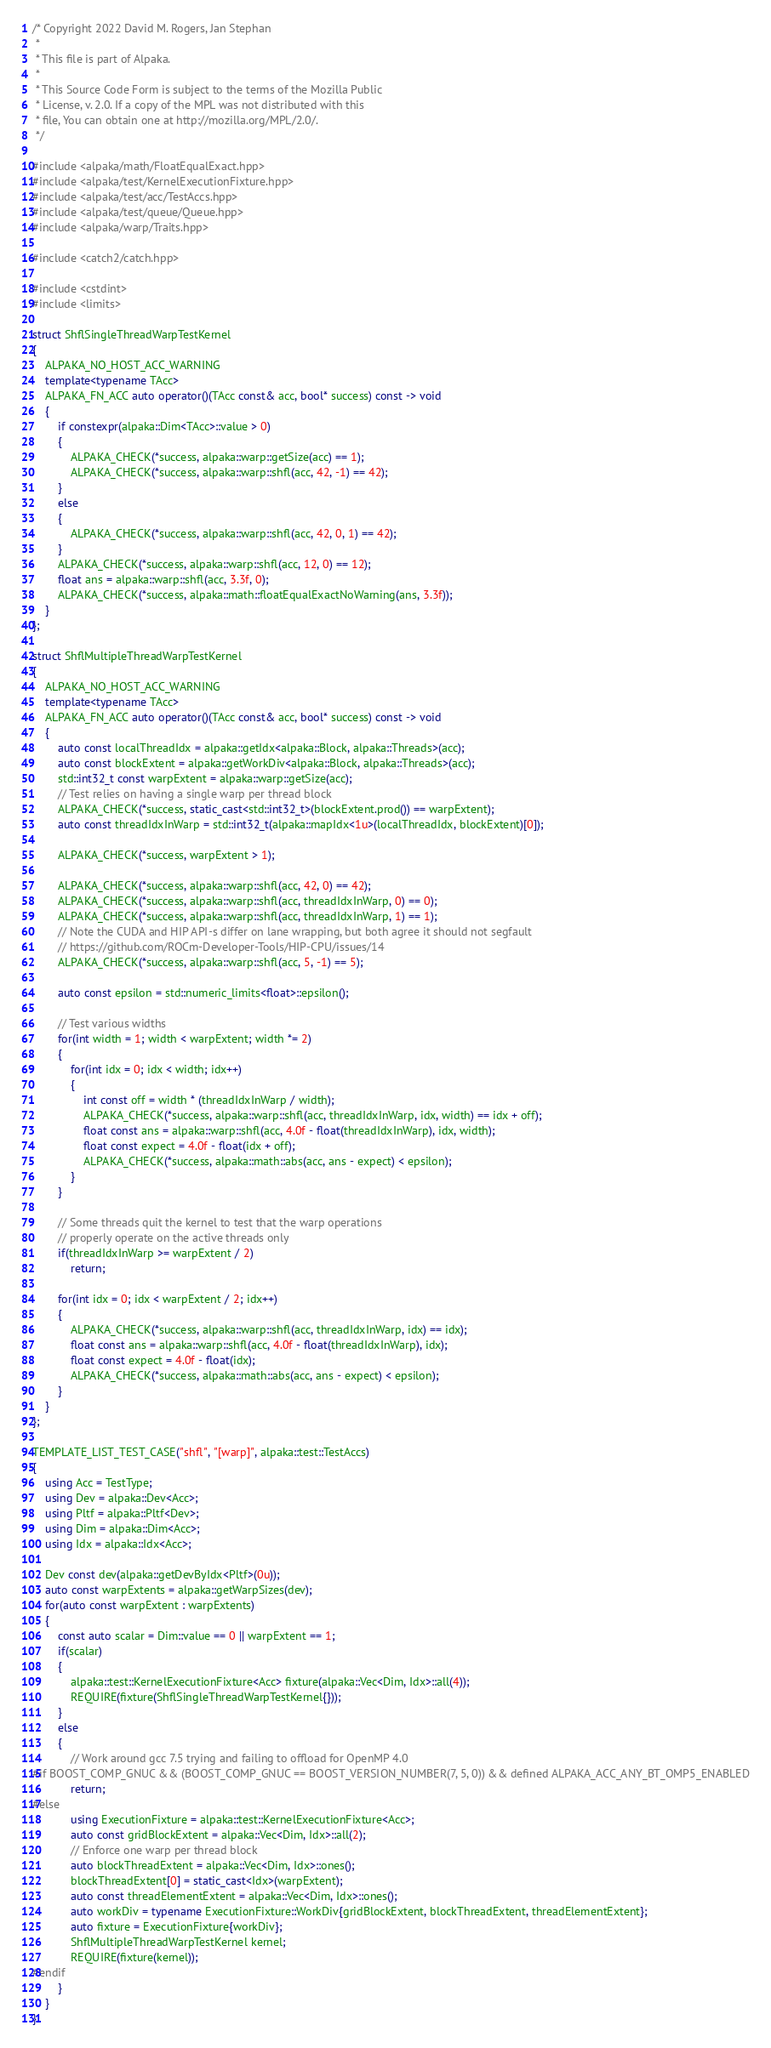<code> <loc_0><loc_0><loc_500><loc_500><_C++_>/* Copyright 2022 David M. Rogers, Jan Stephan
 *
 * This file is part of Alpaka.
 *
 * This Source Code Form is subject to the terms of the Mozilla Public
 * License, v. 2.0. If a copy of the MPL was not distributed with this
 * file, You can obtain one at http://mozilla.org/MPL/2.0/.
 */

#include <alpaka/math/FloatEqualExact.hpp>
#include <alpaka/test/KernelExecutionFixture.hpp>
#include <alpaka/test/acc/TestAccs.hpp>
#include <alpaka/test/queue/Queue.hpp>
#include <alpaka/warp/Traits.hpp>

#include <catch2/catch.hpp>

#include <cstdint>
#include <limits>

struct ShflSingleThreadWarpTestKernel
{
    ALPAKA_NO_HOST_ACC_WARNING
    template<typename TAcc>
    ALPAKA_FN_ACC auto operator()(TAcc const& acc, bool* success) const -> void
    {
        if constexpr(alpaka::Dim<TAcc>::value > 0)
        {
            ALPAKA_CHECK(*success, alpaka::warp::getSize(acc) == 1);
            ALPAKA_CHECK(*success, alpaka::warp::shfl(acc, 42, -1) == 42);
        }
        else
        {
            ALPAKA_CHECK(*success, alpaka::warp::shfl(acc, 42, 0, 1) == 42);
        }
        ALPAKA_CHECK(*success, alpaka::warp::shfl(acc, 12, 0) == 12);
        float ans = alpaka::warp::shfl(acc, 3.3f, 0);
        ALPAKA_CHECK(*success, alpaka::math::floatEqualExactNoWarning(ans, 3.3f));
    }
};

struct ShflMultipleThreadWarpTestKernel
{
    ALPAKA_NO_HOST_ACC_WARNING
    template<typename TAcc>
    ALPAKA_FN_ACC auto operator()(TAcc const& acc, bool* success) const -> void
    {
        auto const localThreadIdx = alpaka::getIdx<alpaka::Block, alpaka::Threads>(acc);
        auto const blockExtent = alpaka::getWorkDiv<alpaka::Block, alpaka::Threads>(acc);
        std::int32_t const warpExtent = alpaka::warp::getSize(acc);
        // Test relies on having a single warp per thread block
        ALPAKA_CHECK(*success, static_cast<std::int32_t>(blockExtent.prod()) == warpExtent);
        auto const threadIdxInWarp = std::int32_t(alpaka::mapIdx<1u>(localThreadIdx, blockExtent)[0]);

        ALPAKA_CHECK(*success, warpExtent > 1);

        ALPAKA_CHECK(*success, alpaka::warp::shfl(acc, 42, 0) == 42);
        ALPAKA_CHECK(*success, alpaka::warp::shfl(acc, threadIdxInWarp, 0) == 0);
        ALPAKA_CHECK(*success, alpaka::warp::shfl(acc, threadIdxInWarp, 1) == 1);
        // Note the CUDA and HIP API-s differ on lane wrapping, but both agree it should not segfault
        // https://github.com/ROCm-Developer-Tools/HIP-CPU/issues/14
        ALPAKA_CHECK(*success, alpaka::warp::shfl(acc, 5, -1) == 5);

        auto const epsilon = std::numeric_limits<float>::epsilon();

        // Test various widths
        for(int width = 1; width < warpExtent; width *= 2)
        {
            for(int idx = 0; idx < width; idx++)
            {
                int const off = width * (threadIdxInWarp / width);
                ALPAKA_CHECK(*success, alpaka::warp::shfl(acc, threadIdxInWarp, idx, width) == idx + off);
                float const ans = alpaka::warp::shfl(acc, 4.0f - float(threadIdxInWarp), idx, width);
                float const expect = 4.0f - float(idx + off);
                ALPAKA_CHECK(*success, alpaka::math::abs(acc, ans - expect) < epsilon);
            }
        }

        // Some threads quit the kernel to test that the warp operations
        // properly operate on the active threads only
        if(threadIdxInWarp >= warpExtent / 2)
            return;

        for(int idx = 0; idx < warpExtent / 2; idx++)
        {
            ALPAKA_CHECK(*success, alpaka::warp::shfl(acc, threadIdxInWarp, idx) == idx);
            float const ans = alpaka::warp::shfl(acc, 4.0f - float(threadIdxInWarp), idx);
            float const expect = 4.0f - float(idx);
            ALPAKA_CHECK(*success, alpaka::math::abs(acc, ans - expect) < epsilon);
        }
    }
};

TEMPLATE_LIST_TEST_CASE("shfl", "[warp]", alpaka::test::TestAccs)
{
    using Acc = TestType;
    using Dev = alpaka::Dev<Acc>;
    using Pltf = alpaka::Pltf<Dev>;
    using Dim = alpaka::Dim<Acc>;
    using Idx = alpaka::Idx<Acc>;

    Dev const dev(alpaka::getDevByIdx<Pltf>(0u));
    auto const warpExtents = alpaka::getWarpSizes(dev);
    for(auto const warpExtent : warpExtents)
    {
        const auto scalar = Dim::value == 0 || warpExtent == 1;
        if(scalar)
        {
            alpaka::test::KernelExecutionFixture<Acc> fixture(alpaka::Vec<Dim, Idx>::all(4));
            REQUIRE(fixture(ShflSingleThreadWarpTestKernel{}));
        }
        else
        {
            // Work around gcc 7.5 trying and failing to offload for OpenMP 4.0
#if BOOST_COMP_GNUC && (BOOST_COMP_GNUC == BOOST_VERSION_NUMBER(7, 5, 0)) && defined ALPAKA_ACC_ANY_BT_OMP5_ENABLED
            return;
#else
            using ExecutionFixture = alpaka::test::KernelExecutionFixture<Acc>;
            auto const gridBlockExtent = alpaka::Vec<Dim, Idx>::all(2);
            // Enforce one warp per thread block
            auto blockThreadExtent = alpaka::Vec<Dim, Idx>::ones();
            blockThreadExtent[0] = static_cast<Idx>(warpExtent);
            auto const threadElementExtent = alpaka::Vec<Dim, Idx>::ones();
            auto workDiv = typename ExecutionFixture::WorkDiv{gridBlockExtent, blockThreadExtent, threadElementExtent};
            auto fixture = ExecutionFixture{workDiv};
            ShflMultipleThreadWarpTestKernel kernel;
            REQUIRE(fixture(kernel));
#endif
        }
    }
}
</code> 